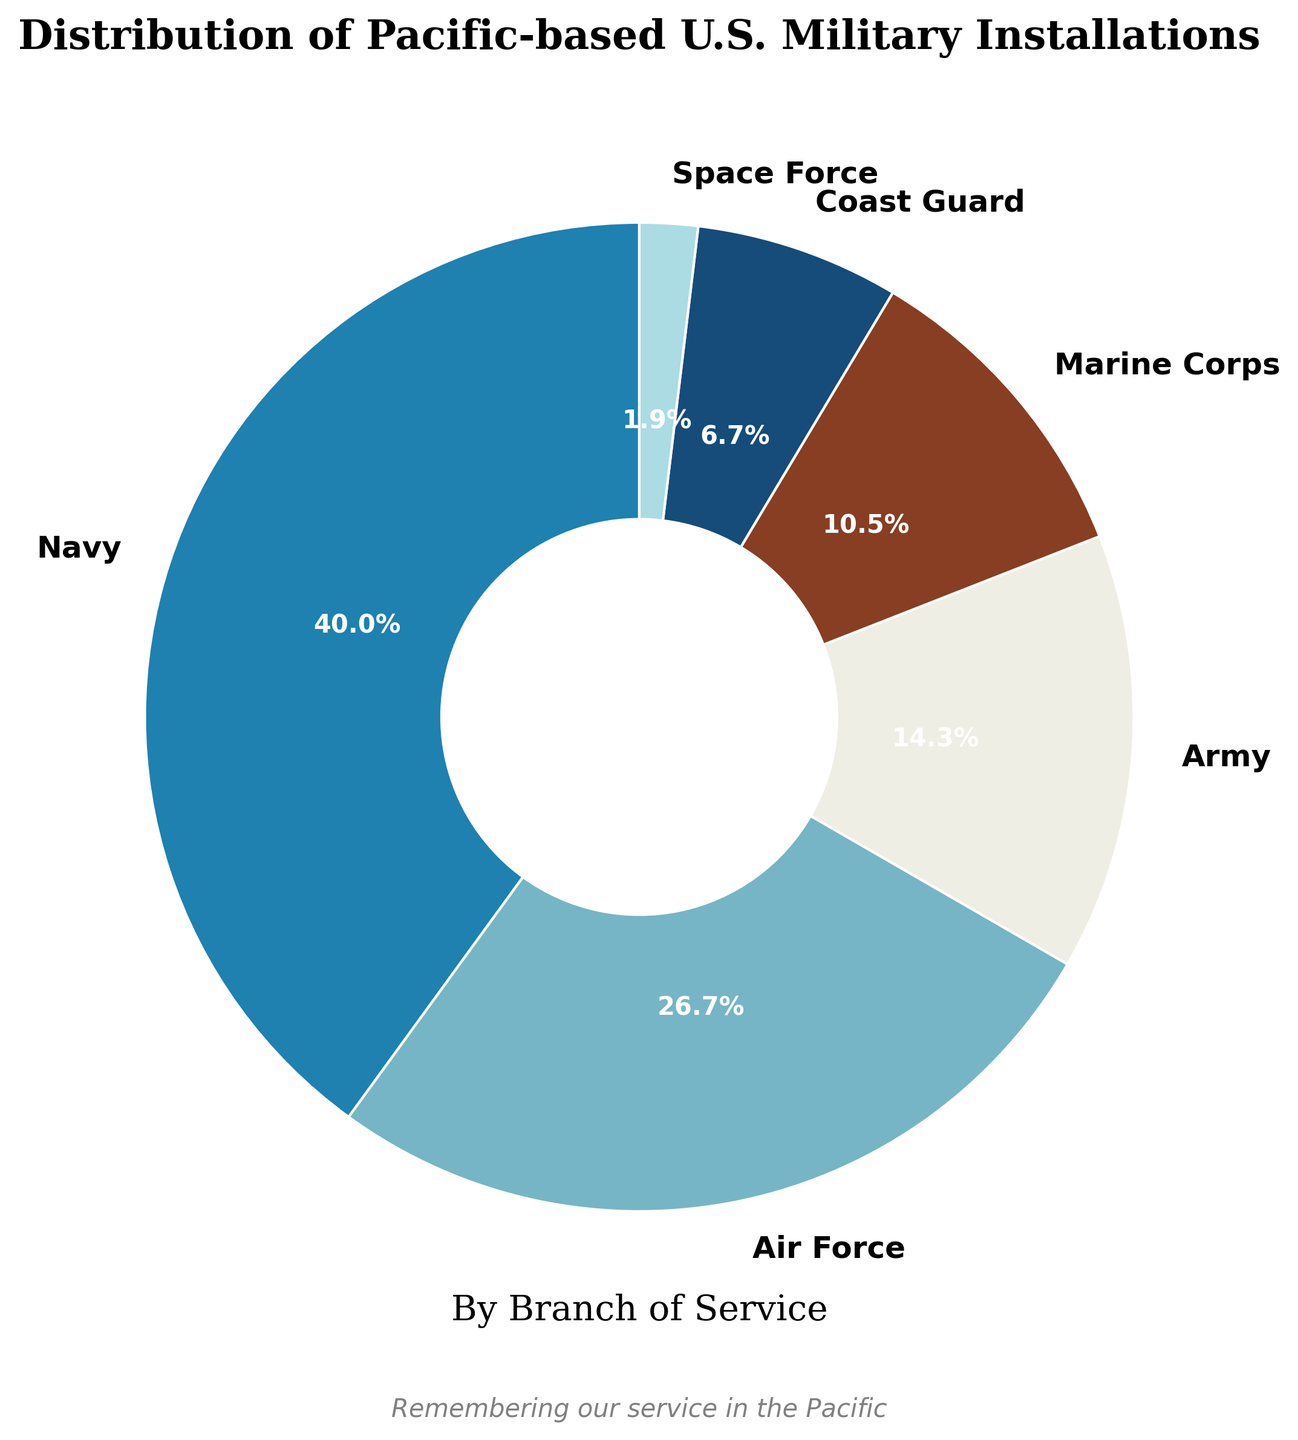What is the proportion of Navy installations compared to the total? The Navy has 42 installations. To find the proportion, we need the total number of installations from all branches, which is 42 (Navy) + 28 (Air Force) + 15 (Army) + 11 (Marine Corps) + 7 (Coast Guard) + 2 (Space Force) = 105. The proportion of Navy installations is then 42/105.
Answer: 40% Which branch has the least number of installations? By observing the figure, it's clear that the Space Force has the fewest installations.
Answer: Space Force How many more Navy installations are there compared to Army installations? The Navy has 42 installations, and the Army has 15. The difference is 42 - 15.
Answer: 27 What is the combined percentage of installations for Marine Corps and Coast Guard? The Marine Corps has 11 installations and the Coast Guard has 7. Combined, they have 11 + 7 = 18 installations. To find their percentage, use (18 / 105) * 100.
Answer: 17.1% Does the Air Force have more installations than the Army and Marine Corps combined? The Air Force has 28 installations. The Army and Marine Corps combined have 15 (Army) + 11 (Marine Corps) = 26. So, 28 Air Force installations are more than 26 combined installations of the Army and Marine Corps.
Answer: Yes Which branch occupies the lightest color section in the pie chart? From the figure, the lightest color section represents the Army, as it uses the third color in the prescribed sequence after Navy and Air Force.
Answer: Army If we merged the installations of the Coast Guard and the Space Force, would their combined total exceed those of the Marine Corps? Coast Guard has 7 installations and Space Force has 2. Together they have 7 + 2 = 9 installations. The Marine Corps has 11 installations, so 9 is not more than 11.
Answer: No What percentage of the pie chart is occupied by the two least represented branches? The Space Force and Coast Guard are the least represented. Space Force has 2 and Coast Guard has 7 installations. Together they have 2 + 7 = 9 installations. Their percentage is (9 / 105) * 100.
Answer: 8.6% Compare the total installations of the Navy and the Air Force combined to the rest of the branches. The Navy has 42 and the Air Force has 28 installations, together they have 42 + 28 = 70. The total installations of all branches is 105, so the rest of the branches have 105 - 70 = 35 installations. 70 is much larger than 35.
Answer: Navy and Air Force together have more Which branch has the highest representation and what is its corresponding color? The branch with the highest number of installations is the Navy with 42. Its corresponding color, based on the pie chart, is represented by the first color in the specified sequence.
Answer: Navy with a dark blue color 